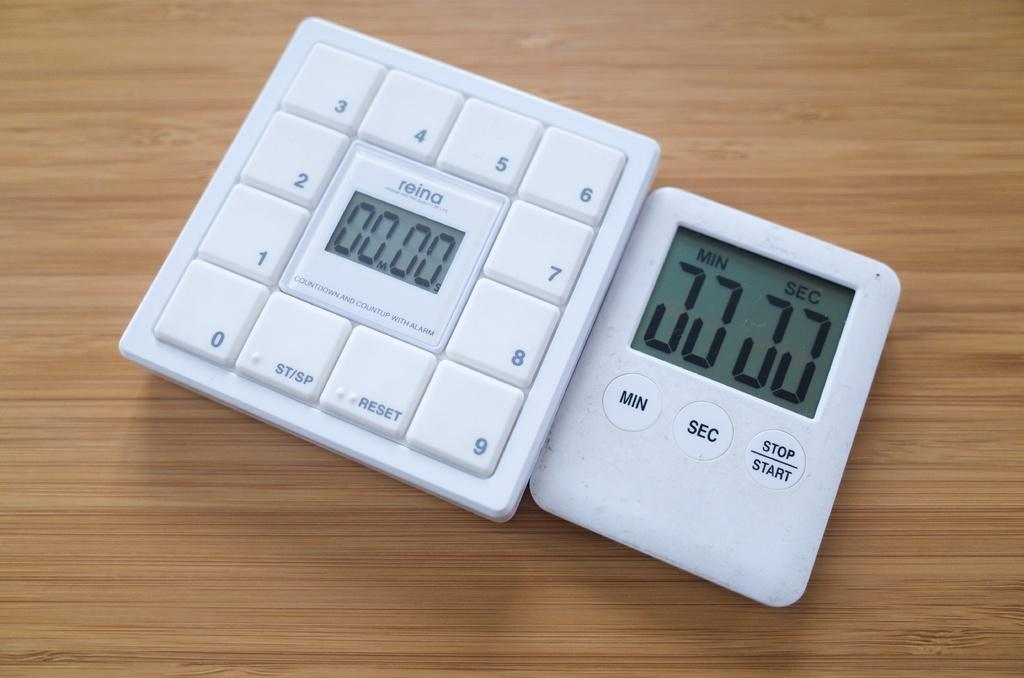<image>
Write a terse but informative summary of the picture. a white object with 00.00 on it and other numbers 